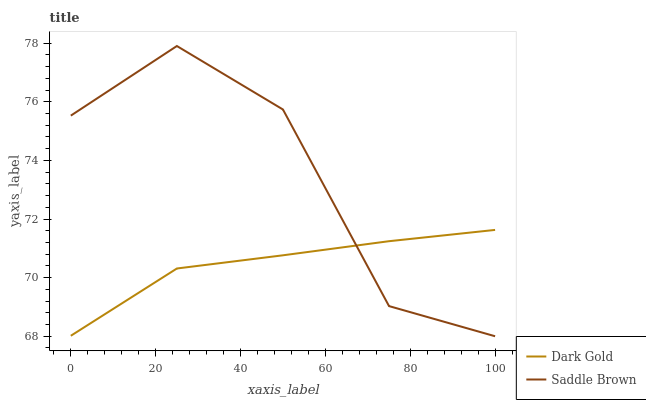Does Dark Gold have the minimum area under the curve?
Answer yes or no. Yes. Does Saddle Brown have the maximum area under the curve?
Answer yes or no. Yes. Does Dark Gold have the maximum area under the curve?
Answer yes or no. No. Is Dark Gold the smoothest?
Answer yes or no. Yes. Is Saddle Brown the roughest?
Answer yes or no. Yes. Is Dark Gold the roughest?
Answer yes or no. No. Does Saddle Brown have the lowest value?
Answer yes or no. Yes. Does Dark Gold have the lowest value?
Answer yes or no. No. Does Saddle Brown have the highest value?
Answer yes or no. Yes. Does Dark Gold have the highest value?
Answer yes or no. No. Does Saddle Brown intersect Dark Gold?
Answer yes or no. Yes. Is Saddle Brown less than Dark Gold?
Answer yes or no. No. Is Saddle Brown greater than Dark Gold?
Answer yes or no. No. 